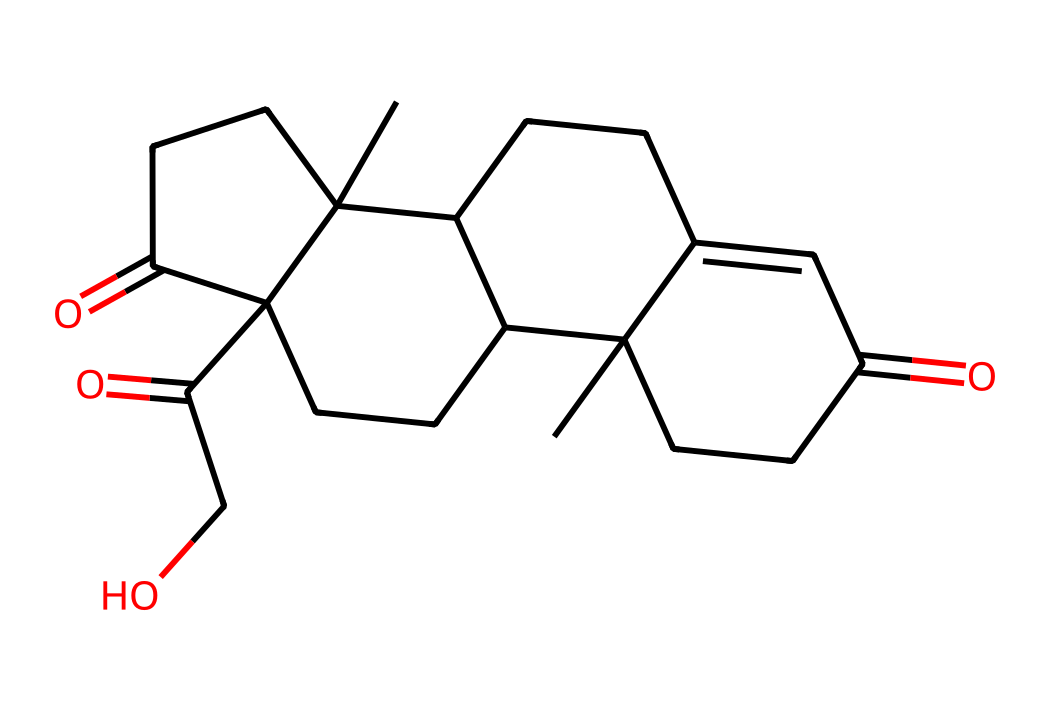What is the molecular formula of cortisol? To determine the molecular formula, we count the number of each type of atom in the SMILES representation. By interpreting the structure, we find 21 carbons, 30 hydrogens, and 5 oxygens, leading to the molecular formula C21H30O5.
Answer: C21H30O5 How many rings are present in the cortisol structure? By analyzing the structure within the SMILES, we identify multiple cyclic components. Specifically, there are four interconnected rings in the structure of cortisol.
Answer: 4 What functional groups are present in cortisol? Analyzing the chemical structure, we identify carbonyl (C=O) groups on both the ketone and aldehyde sides, as well as hydroxyl (–OH) groups. This indicates the presence of ketone and alcohol functional groups.
Answer: ketone and alcohol Does cortisol contain any double bonds? By examining the structure detailed in the SMILES notation, we see that there are several C=C double bonds present amongst the cyclic structures of cortisol.
Answer: yes What type of hormone is cortisol categorized as? Based on the structural characteristics and its functions in the body, cortisol is categorized as a steroid hormone, which is indicated by its steroidal backbone structure.
Answer: steroid hormone Which component of cortisol is primarily responsible for its anti-inflammatory effects? The presence of specific hydroxyl and carbonyl groups in the structure contributes to cortisol's ability to modulate inflammation, allowing cortisol to bind to glucocorticoid receptors.
Answer: hydroxyl and carbonyl groups What is the significance of the number of carbon atoms in cortisol? The number of carbon atoms in cortisol informs us about its classification as a steroid, as steroids typically have a core structure of four fused carbon rings and a carbon count ranging from 21-27.
Answer: 21 